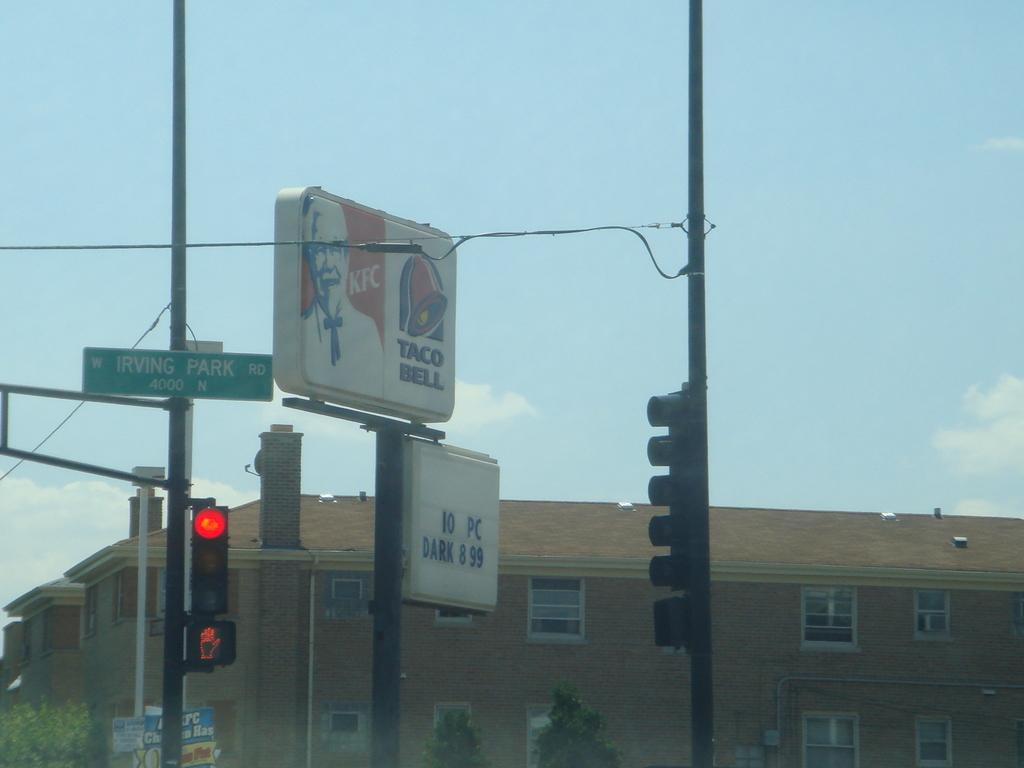<image>
Offer a succinct explanation of the picture presented. A sign next to some stop lights that reads KFC TACO BELL. 